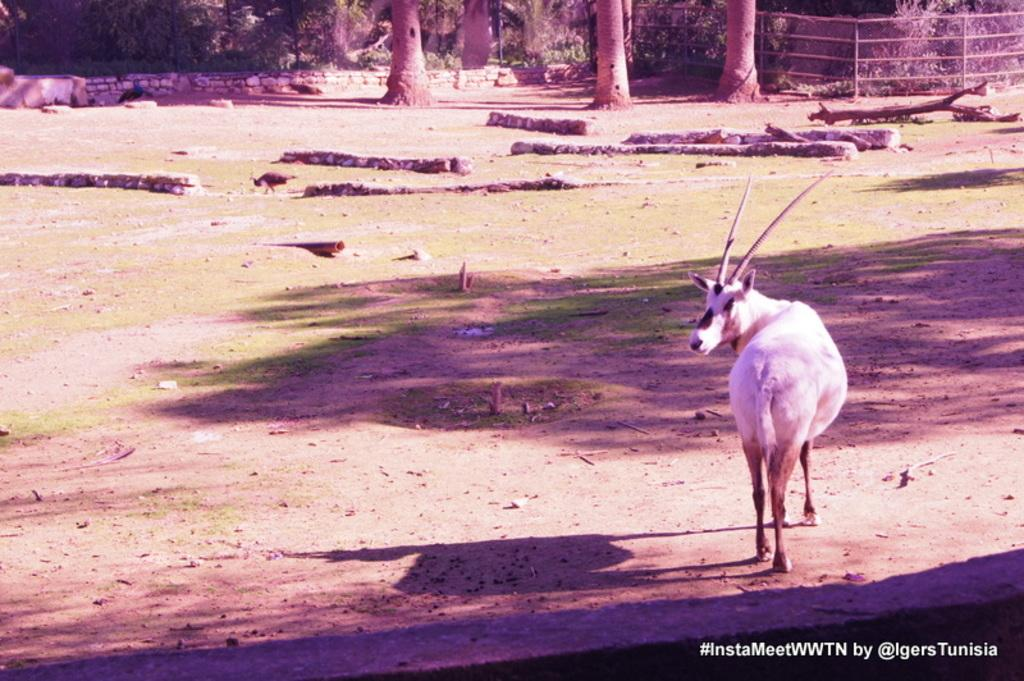What type of creature is in the image? There is an animal in the image. Where is the animal located? The animal is standing on land. What can be seen in front of the animal? There are many trees in front of the animal. What object is on the right side of the image? There is a wooden log on the right side of the image. How does the animal contribute to reducing pollution in the image? The image does not provide information about the animal's role in reducing pollution, nor is there any indication of pollution in the image. 